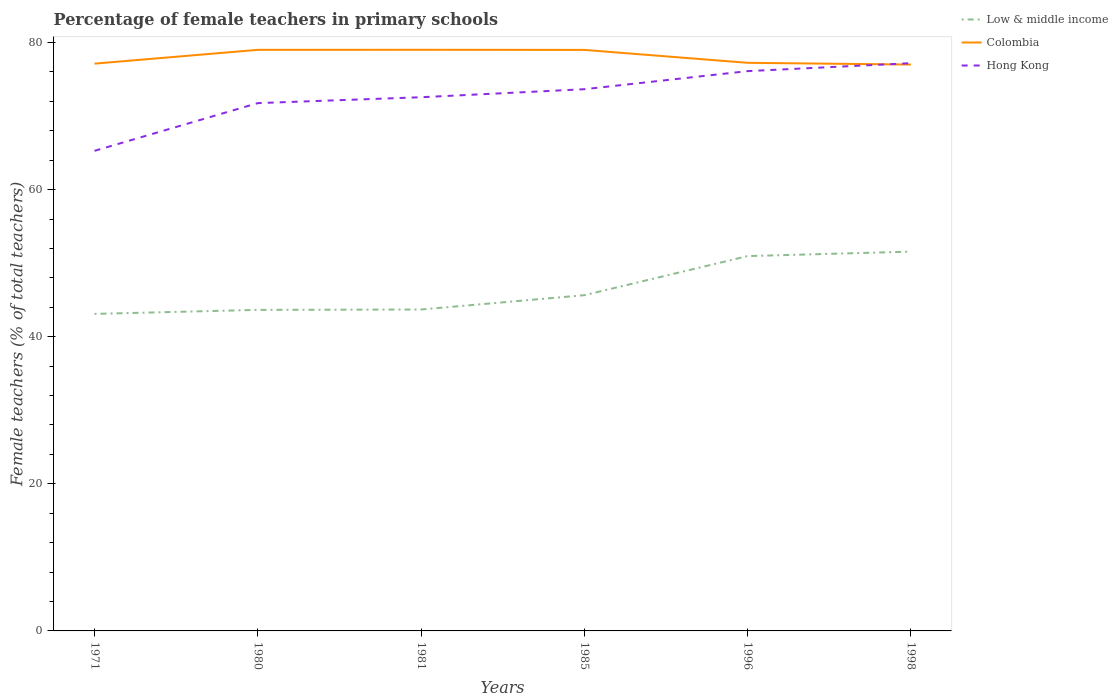Across all years, what is the maximum percentage of female teachers in Hong Kong?
Provide a succinct answer. 65.27. In which year was the percentage of female teachers in Colombia maximum?
Make the answer very short. 1998. What is the total percentage of female teachers in Hong Kong in the graph?
Your response must be concise. -0.8. What is the difference between the highest and the second highest percentage of female teachers in Hong Kong?
Your answer should be compact. 11.92. What is the difference between the highest and the lowest percentage of female teachers in Colombia?
Your response must be concise. 3. Is the percentage of female teachers in Hong Kong strictly greater than the percentage of female teachers in Low & middle income over the years?
Your answer should be very brief. No. Does the graph contain any zero values?
Keep it short and to the point. No. Where does the legend appear in the graph?
Provide a succinct answer. Top right. How are the legend labels stacked?
Offer a terse response. Vertical. What is the title of the graph?
Ensure brevity in your answer.  Percentage of female teachers in primary schools. What is the label or title of the Y-axis?
Your response must be concise. Female teachers (% of total teachers). What is the Female teachers (% of total teachers) of Low & middle income in 1971?
Your answer should be very brief. 43.1. What is the Female teachers (% of total teachers) in Colombia in 1971?
Your answer should be compact. 77.13. What is the Female teachers (% of total teachers) in Hong Kong in 1971?
Give a very brief answer. 65.27. What is the Female teachers (% of total teachers) of Low & middle income in 1980?
Offer a very short reply. 43.65. What is the Female teachers (% of total teachers) in Colombia in 1980?
Give a very brief answer. 79. What is the Female teachers (% of total teachers) in Hong Kong in 1980?
Your answer should be very brief. 71.76. What is the Female teachers (% of total teachers) in Low & middle income in 1981?
Your answer should be very brief. 43.7. What is the Female teachers (% of total teachers) in Colombia in 1981?
Make the answer very short. 79.01. What is the Female teachers (% of total teachers) of Hong Kong in 1981?
Make the answer very short. 72.56. What is the Female teachers (% of total teachers) of Low & middle income in 1985?
Your answer should be compact. 45.65. What is the Female teachers (% of total teachers) in Colombia in 1985?
Your response must be concise. 78.99. What is the Female teachers (% of total teachers) of Hong Kong in 1985?
Offer a very short reply. 73.65. What is the Female teachers (% of total teachers) in Low & middle income in 1996?
Make the answer very short. 50.96. What is the Female teachers (% of total teachers) of Colombia in 1996?
Your answer should be very brief. 77.24. What is the Female teachers (% of total teachers) in Hong Kong in 1996?
Offer a terse response. 76.11. What is the Female teachers (% of total teachers) in Low & middle income in 1998?
Ensure brevity in your answer.  51.57. What is the Female teachers (% of total teachers) of Colombia in 1998?
Your answer should be very brief. 77. What is the Female teachers (% of total teachers) in Hong Kong in 1998?
Ensure brevity in your answer.  77.19. Across all years, what is the maximum Female teachers (% of total teachers) of Low & middle income?
Offer a very short reply. 51.57. Across all years, what is the maximum Female teachers (% of total teachers) of Colombia?
Offer a very short reply. 79.01. Across all years, what is the maximum Female teachers (% of total teachers) in Hong Kong?
Provide a succinct answer. 77.19. Across all years, what is the minimum Female teachers (% of total teachers) of Low & middle income?
Ensure brevity in your answer.  43.1. Across all years, what is the minimum Female teachers (% of total teachers) of Colombia?
Your answer should be compact. 77. Across all years, what is the minimum Female teachers (% of total teachers) of Hong Kong?
Offer a terse response. 65.27. What is the total Female teachers (% of total teachers) in Low & middle income in the graph?
Ensure brevity in your answer.  278.63. What is the total Female teachers (% of total teachers) of Colombia in the graph?
Your answer should be compact. 468.38. What is the total Female teachers (% of total teachers) of Hong Kong in the graph?
Keep it short and to the point. 436.54. What is the difference between the Female teachers (% of total teachers) of Low & middle income in 1971 and that in 1980?
Your answer should be compact. -0.55. What is the difference between the Female teachers (% of total teachers) in Colombia in 1971 and that in 1980?
Your answer should be very brief. -1.88. What is the difference between the Female teachers (% of total teachers) of Hong Kong in 1971 and that in 1980?
Ensure brevity in your answer.  -6.49. What is the difference between the Female teachers (% of total teachers) in Low & middle income in 1971 and that in 1981?
Your answer should be compact. -0.6. What is the difference between the Female teachers (% of total teachers) of Colombia in 1971 and that in 1981?
Offer a terse response. -1.89. What is the difference between the Female teachers (% of total teachers) in Hong Kong in 1971 and that in 1981?
Provide a succinct answer. -7.29. What is the difference between the Female teachers (% of total teachers) of Low & middle income in 1971 and that in 1985?
Keep it short and to the point. -2.54. What is the difference between the Female teachers (% of total teachers) in Colombia in 1971 and that in 1985?
Offer a very short reply. -1.87. What is the difference between the Female teachers (% of total teachers) in Hong Kong in 1971 and that in 1985?
Keep it short and to the point. -8.38. What is the difference between the Female teachers (% of total teachers) in Low & middle income in 1971 and that in 1996?
Your answer should be compact. -7.86. What is the difference between the Female teachers (% of total teachers) of Colombia in 1971 and that in 1996?
Provide a short and direct response. -0.11. What is the difference between the Female teachers (% of total teachers) of Hong Kong in 1971 and that in 1996?
Offer a very short reply. -10.84. What is the difference between the Female teachers (% of total teachers) of Low & middle income in 1971 and that in 1998?
Your answer should be compact. -8.47. What is the difference between the Female teachers (% of total teachers) of Colombia in 1971 and that in 1998?
Make the answer very short. 0.12. What is the difference between the Female teachers (% of total teachers) of Hong Kong in 1971 and that in 1998?
Ensure brevity in your answer.  -11.92. What is the difference between the Female teachers (% of total teachers) of Low & middle income in 1980 and that in 1981?
Offer a very short reply. -0.05. What is the difference between the Female teachers (% of total teachers) of Colombia in 1980 and that in 1981?
Make the answer very short. -0.01. What is the difference between the Female teachers (% of total teachers) of Low & middle income in 1980 and that in 1985?
Ensure brevity in your answer.  -2. What is the difference between the Female teachers (% of total teachers) in Colombia in 1980 and that in 1985?
Your answer should be very brief. 0.01. What is the difference between the Female teachers (% of total teachers) in Hong Kong in 1980 and that in 1985?
Make the answer very short. -1.89. What is the difference between the Female teachers (% of total teachers) of Low & middle income in 1980 and that in 1996?
Ensure brevity in your answer.  -7.31. What is the difference between the Female teachers (% of total teachers) of Colombia in 1980 and that in 1996?
Your response must be concise. 1.76. What is the difference between the Female teachers (% of total teachers) of Hong Kong in 1980 and that in 1996?
Your response must be concise. -4.35. What is the difference between the Female teachers (% of total teachers) in Low & middle income in 1980 and that in 1998?
Offer a terse response. -7.92. What is the difference between the Female teachers (% of total teachers) of Colombia in 1980 and that in 1998?
Provide a succinct answer. 2. What is the difference between the Female teachers (% of total teachers) of Hong Kong in 1980 and that in 1998?
Your answer should be very brief. -5.43. What is the difference between the Female teachers (% of total teachers) of Low & middle income in 1981 and that in 1985?
Your answer should be very brief. -1.95. What is the difference between the Female teachers (% of total teachers) in Colombia in 1981 and that in 1985?
Your answer should be compact. 0.02. What is the difference between the Female teachers (% of total teachers) in Hong Kong in 1981 and that in 1985?
Offer a terse response. -1.09. What is the difference between the Female teachers (% of total teachers) in Low & middle income in 1981 and that in 1996?
Your answer should be compact. -7.26. What is the difference between the Female teachers (% of total teachers) in Colombia in 1981 and that in 1996?
Give a very brief answer. 1.77. What is the difference between the Female teachers (% of total teachers) of Hong Kong in 1981 and that in 1996?
Offer a very short reply. -3.55. What is the difference between the Female teachers (% of total teachers) in Low & middle income in 1981 and that in 1998?
Provide a short and direct response. -7.87. What is the difference between the Female teachers (% of total teachers) in Colombia in 1981 and that in 1998?
Offer a terse response. 2.01. What is the difference between the Female teachers (% of total teachers) in Hong Kong in 1981 and that in 1998?
Give a very brief answer. -4.63. What is the difference between the Female teachers (% of total teachers) of Low & middle income in 1985 and that in 1996?
Give a very brief answer. -5.31. What is the difference between the Female teachers (% of total teachers) of Colombia in 1985 and that in 1996?
Offer a terse response. 1.75. What is the difference between the Female teachers (% of total teachers) in Hong Kong in 1985 and that in 1996?
Your response must be concise. -2.46. What is the difference between the Female teachers (% of total teachers) of Low & middle income in 1985 and that in 1998?
Provide a succinct answer. -5.92. What is the difference between the Female teachers (% of total teachers) of Colombia in 1985 and that in 1998?
Ensure brevity in your answer.  1.99. What is the difference between the Female teachers (% of total teachers) of Hong Kong in 1985 and that in 1998?
Offer a very short reply. -3.54. What is the difference between the Female teachers (% of total teachers) in Low & middle income in 1996 and that in 1998?
Your answer should be very brief. -0.61. What is the difference between the Female teachers (% of total teachers) of Colombia in 1996 and that in 1998?
Your answer should be very brief. 0.24. What is the difference between the Female teachers (% of total teachers) of Hong Kong in 1996 and that in 1998?
Provide a succinct answer. -1.08. What is the difference between the Female teachers (% of total teachers) of Low & middle income in 1971 and the Female teachers (% of total teachers) of Colombia in 1980?
Give a very brief answer. -35.9. What is the difference between the Female teachers (% of total teachers) of Low & middle income in 1971 and the Female teachers (% of total teachers) of Hong Kong in 1980?
Keep it short and to the point. -28.66. What is the difference between the Female teachers (% of total teachers) of Colombia in 1971 and the Female teachers (% of total teachers) of Hong Kong in 1980?
Provide a succinct answer. 5.37. What is the difference between the Female teachers (% of total teachers) of Low & middle income in 1971 and the Female teachers (% of total teachers) of Colombia in 1981?
Make the answer very short. -35.91. What is the difference between the Female teachers (% of total teachers) in Low & middle income in 1971 and the Female teachers (% of total teachers) in Hong Kong in 1981?
Keep it short and to the point. -29.46. What is the difference between the Female teachers (% of total teachers) in Colombia in 1971 and the Female teachers (% of total teachers) in Hong Kong in 1981?
Offer a very short reply. 4.57. What is the difference between the Female teachers (% of total teachers) of Low & middle income in 1971 and the Female teachers (% of total teachers) of Colombia in 1985?
Your response must be concise. -35.89. What is the difference between the Female teachers (% of total teachers) of Low & middle income in 1971 and the Female teachers (% of total teachers) of Hong Kong in 1985?
Ensure brevity in your answer.  -30.55. What is the difference between the Female teachers (% of total teachers) in Colombia in 1971 and the Female teachers (% of total teachers) in Hong Kong in 1985?
Offer a terse response. 3.47. What is the difference between the Female teachers (% of total teachers) of Low & middle income in 1971 and the Female teachers (% of total teachers) of Colombia in 1996?
Provide a succinct answer. -34.14. What is the difference between the Female teachers (% of total teachers) in Low & middle income in 1971 and the Female teachers (% of total teachers) in Hong Kong in 1996?
Keep it short and to the point. -33.01. What is the difference between the Female teachers (% of total teachers) of Low & middle income in 1971 and the Female teachers (% of total teachers) of Colombia in 1998?
Ensure brevity in your answer.  -33.9. What is the difference between the Female teachers (% of total teachers) of Low & middle income in 1971 and the Female teachers (% of total teachers) of Hong Kong in 1998?
Your response must be concise. -34.09. What is the difference between the Female teachers (% of total teachers) in Colombia in 1971 and the Female teachers (% of total teachers) in Hong Kong in 1998?
Your response must be concise. -0.07. What is the difference between the Female teachers (% of total teachers) of Low & middle income in 1980 and the Female teachers (% of total teachers) of Colombia in 1981?
Your answer should be very brief. -35.36. What is the difference between the Female teachers (% of total teachers) in Low & middle income in 1980 and the Female teachers (% of total teachers) in Hong Kong in 1981?
Keep it short and to the point. -28.91. What is the difference between the Female teachers (% of total teachers) in Colombia in 1980 and the Female teachers (% of total teachers) in Hong Kong in 1981?
Your answer should be very brief. 6.44. What is the difference between the Female teachers (% of total teachers) in Low & middle income in 1980 and the Female teachers (% of total teachers) in Colombia in 1985?
Offer a very short reply. -35.34. What is the difference between the Female teachers (% of total teachers) of Low & middle income in 1980 and the Female teachers (% of total teachers) of Hong Kong in 1985?
Offer a very short reply. -30. What is the difference between the Female teachers (% of total teachers) of Colombia in 1980 and the Female teachers (% of total teachers) of Hong Kong in 1985?
Keep it short and to the point. 5.35. What is the difference between the Female teachers (% of total teachers) of Low & middle income in 1980 and the Female teachers (% of total teachers) of Colombia in 1996?
Your answer should be compact. -33.59. What is the difference between the Female teachers (% of total teachers) of Low & middle income in 1980 and the Female teachers (% of total teachers) of Hong Kong in 1996?
Your answer should be compact. -32.46. What is the difference between the Female teachers (% of total teachers) of Colombia in 1980 and the Female teachers (% of total teachers) of Hong Kong in 1996?
Your answer should be very brief. 2.89. What is the difference between the Female teachers (% of total teachers) in Low & middle income in 1980 and the Female teachers (% of total teachers) in Colombia in 1998?
Your answer should be very brief. -33.36. What is the difference between the Female teachers (% of total teachers) of Low & middle income in 1980 and the Female teachers (% of total teachers) of Hong Kong in 1998?
Provide a short and direct response. -33.54. What is the difference between the Female teachers (% of total teachers) of Colombia in 1980 and the Female teachers (% of total teachers) of Hong Kong in 1998?
Offer a terse response. 1.81. What is the difference between the Female teachers (% of total teachers) of Low & middle income in 1981 and the Female teachers (% of total teachers) of Colombia in 1985?
Make the answer very short. -35.29. What is the difference between the Female teachers (% of total teachers) of Low & middle income in 1981 and the Female teachers (% of total teachers) of Hong Kong in 1985?
Provide a succinct answer. -29.95. What is the difference between the Female teachers (% of total teachers) of Colombia in 1981 and the Female teachers (% of total teachers) of Hong Kong in 1985?
Your response must be concise. 5.36. What is the difference between the Female teachers (% of total teachers) in Low & middle income in 1981 and the Female teachers (% of total teachers) in Colombia in 1996?
Provide a short and direct response. -33.54. What is the difference between the Female teachers (% of total teachers) in Low & middle income in 1981 and the Female teachers (% of total teachers) in Hong Kong in 1996?
Your answer should be very brief. -32.41. What is the difference between the Female teachers (% of total teachers) in Colombia in 1981 and the Female teachers (% of total teachers) in Hong Kong in 1996?
Provide a succinct answer. 2.9. What is the difference between the Female teachers (% of total teachers) in Low & middle income in 1981 and the Female teachers (% of total teachers) in Colombia in 1998?
Offer a very short reply. -33.3. What is the difference between the Female teachers (% of total teachers) in Low & middle income in 1981 and the Female teachers (% of total teachers) in Hong Kong in 1998?
Give a very brief answer. -33.49. What is the difference between the Female teachers (% of total teachers) of Colombia in 1981 and the Female teachers (% of total teachers) of Hong Kong in 1998?
Your response must be concise. 1.82. What is the difference between the Female teachers (% of total teachers) of Low & middle income in 1985 and the Female teachers (% of total teachers) of Colombia in 1996?
Make the answer very short. -31.59. What is the difference between the Female teachers (% of total teachers) in Low & middle income in 1985 and the Female teachers (% of total teachers) in Hong Kong in 1996?
Offer a terse response. -30.46. What is the difference between the Female teachers (% of total teachers) in Colombia in 1985 and the Female teachers (% of total teachers) in Hong Kong in 1996?
Your answer should be compact. 2.88. What is the difference between the Female teachers (% of total teachers) in Low & middle income in 1985 and the Female teachers (% of total teachers) in Colombia in 1998?
Your response must be concise. -31.36. What is the difference between the Female teachers (% of total teachers) in Low & middle income in 1985 and the Female teachers (% of total teachers) in Hong Kong in 1998?
Ensure brevity in your answer.  -31.55. What is the difference between the Female teachers (% of total teachers) of Colombia in 1985 and the Female teachers (% of total teachers) of Hong Kong in 1998?
Keep it short and to the point. 1.8. What is the difference between the Female teachers (% of total teachers) in Low & middle income in 1996 and the Female teachers (% of total teachers) in Colombia in 1998?
Make the answer very short. -26.04. What is the difference between the Female teachers (% of total teachers) in Low & middle income in 1996 and the Female teachers (% of total teachers) in Hong Kong in 1998?
Keep it short and to the point. -26.23. What is the difference between the Female teachers (% of total teachers) in Colombia in 1996 and the Female teachers (% of total teachers) in Hong Kong in 1998?
Provide a short and direct response. 0.05. What is the average Female teachers (% of total teachers) of Low & middle income per year?
Keep it short and to the point. 46.44. What is the average Female teachers (% of total teachers) of Colombia per year?
Ensure brevity in your answer.  78.06. What is the average Female teachers (% of total teachers) in Hong Kong per year?
Offer a very short reply. 72.76. In the year 1971, what is the difference between the Female teachers (% of total teachers) of Low & middle income and Female teachers (% of total teachers) of Colombia?
Your answer should be compact. -34.02. In the year 1971, what is the difference between the Female teachers (% of total teachers) in Low & middle income and Female teachers (% of total teachers) in Hong Kong?
Ensure brevity in your answer.  -22.17. In the year 1971, what is the difference between the Female teachers (% of total teachers) of Colombia and Female teachers (% of total teachers) of Hong Kong?
Make the answer very short. 11.85. In the year 1980, what is the difference between the Female teachers (% of total teachers) in Low & middle income and Female teachers (% of total teachers) in Colombia?
Your response must be concise. -35.35. In the year 1980, what is the difference between the Female teachers (% of total teachers) in Low & middle income and Female teachers (% of total teachers) in Hong Kong?
Give a very brief answer. -28.11. In the year 1980, what is the difference between the Female teachers (% of total teachers) in Colombia and Female teachers (% of total teachers) in Hong Kong?
Offer a terse response. 7.24. In the year 1981, what is the difference between the Female teachers (% of total teachers) of Low & middle income and Female teachers (% of total teachers) of Colombia?
Ensure brevity in your answer.  -35.31. In the year 1981, what is the difference between the Female teachers (% of total teachers) of Low & middle income and Female teachers (% of total teachers) of Hong Kong?
Make the answer very short. -28.86. In the year 1981, what is the difference between the Female teachers (% of total teachers) in Colombia and Female teachers (% of total teachers) in Hong Kong?
Provide a succinct answer. 6.45. In the year 1985, what is the difference between the Female teachers (% of total teachers) in Low & middle income and Female teachers (% of total teachers) in Colombia?
Your answer should be compact. -33.35. In the year 1985, what is the difference between the Female teachers (% of total teachers) of Low & middle income and Female teachers (% of total teachers) of Hong Kong?
Your answer should be compact. -28. In the year 1985, what is the difference between the Female teachers (% of total teachers) in Colombia and Female teachers (% of total teachers) in Hong Kong?
Offer a very short reply. 5.34. In the year 1996, what is the difference between the Female teachers (% of total teachers) of Low & middle income and Female teachers (% of total teachers) of Colombia?
Provide a succinct answer. -26.28. In the year 1996, what is the difference between the Female teachers (% of total teachers) in Low & middle income and Female teachers (% of total teachers) in Hong Kong?
Give a very brief answer. -25.15. In the year 1996, what is the difference between the Female teachers (% of total teachers) in Colombia and Female teachers (% of total teachers) in Hong Kong?
Keep it short and to the point. 1.13. In the year 1998, what is the difference between the Female teachers (% of total teachers) in Low & middle income and Female teachers (% of total teachers) in Colombia?
Offer a terse response. -25.44. In the year 1998, what is the difference between the Female teachers (% of total teachers) of Low & middle income and Female teachers (% of total teachers) of Hong Kong?
Your answer should be very brief. -25.62. In the year 1998, what is the difference between the Female teachers (% of total teachers) of Colombia and Female teachers (% of total teachers) of Hong Kong?
Make the answer very short. -0.19. What is the ratio of the Female teachers (% of total teachers) of Low & middle income in 1971 to that in 1980?
Ensure brevity in your answer.  0.99. What is the ratio of the Female teachers (% of total teachers) of Colombia in 1971 to that in 1980?
Make the answer very short. 0.98. What is the ratio of the Female teachers (% of total teachers) in Hong Kong in 1971 to that in 1980?
Your response must be concise. 0.91. What is the ratio of the Female teachers (% of total teachers) in Low & middle income in 1971 to that in 1981?
Offer a terse response. 0.99. What is the ratio of the Female teachers (% of total teachers) of Colombia in 1971 to that in 1981?
Give a very brief answer. 0.98. What is the ratio of the Female teachers (% of total teachers) in Hong Kong in 1971 to that in 1981?
Ensure brevity in your answer.  0.9. What is the ratio of the Female teachers (% of total teachers) of Low & middle income in 1971 to that in 1985?
Keep it short and to the point. 0.94. What is the ratio of the Female teachers (% of total teachers) of Colombia in 1971 to that in 1985?
Your response must be concise. 0.98. What is the ratio of the Female teachers (% of total teachers) of Hong Kong in 1971 to that in 1985?
Your response must be concise. 0.89. What is the ratio of the Female teachers (% of total teachers) of Low & middle income in 1971 to that in 1996?
Make the answer very short. 0.85. What is the ratio of the Female teachers (% of total teachers) in Colombia in 1971 to that in 1996?
Offer a terse response. 1. What is the ratio of the Female teachers (% of total teachers) in Hong Kong in 1971 to that in 1996?
Offer a terse response. 0.86. What is the ratio of the Female teachers (% of total teachers) in Low & middle income in 1971 to that in 1998?
Ensure brevity in your answer.  0.84. What is the ratio of the Female teachers (% of total teachers) of Hong Kong in 1971 to that in 1998?
Keep it short and to the point. 0.85. What is the ratio of the Female teachers (% of total teachers) of Hong Kong in 1980 to that in 1981?
Provide a short and direct response. 0.99. What is the ratio of the Female teachers (% of total teachers) of Low & middle income in 1980 to that in 1985?
Your answer should be very brief. 0.96. What is the ratio of the Female teachers (% of total teachers) in Colombia in 1980 to that in 1985?
Offer a terse response. 1. What is the ratio of the Female teachers (% of total teachers) in Hong Kong in 1980 to that in 1985?
Provide a short and direct response. 0.97. What is the ratio of the Female teachers (% of total teachers) in Low & middle income in 1980 to that in 1996?
Offer a very short reply. 0.86. What is the ratio of the Female teachers (% of total teachers) of Colombia in 1980 to that in 1996?
Provide a short and direct response. 1.02. What is the ratio of the Female teachers (% of total teachers) in Hong Kong in 1980 to that in 1996?
Provide a short and direct response. 0.94. What is the ratio of the Female teachers (% of total teachers) of Low & middle income in 1980 to that in 1998?
Ensure brevity in your answer.  0.85. What is the ratio of the Female teachers (% of total teachers) of Colombia in 1980 to that in 1998?
Your response must be concise. 1.03. What is the ratio of the Female teachers (% of total teachers) in Hong Kong in 1980 to that in 1998?
Make the answer very short. 0.93. What is the ratio of the Female teachers (% of total teachers) in Low & middle income in 1981 to that in 1985?
Your answer should be very brief. 0.96. What is the ratio of the Female teachers (% of total teachers) of Hong Kong in 1981 to that in 1985?
Your response must be concise. 0.99. What is the ratio of the Female teachers (% of total teachers) in Low & middle income in 1981 to that in 1996?
Give a very brief answer. 0.86. What is the ratio of the Female teachers (% of total teachers) in Colombia in 1981 to that in 1996?
Provide a succinct answer. 1.02. What is the ratio of the Female teachers (% of total teachers) in Hong Kong in 1981 to that in 1996?
Your answer should be compact. 0.95. What is the ratio of the Female teachers (% of total teachers) of Low & middle income in 1981 to that in 1998?
Ensure brevity in your answer.  0.85. What is the ratio of the Female teachers (% of total teachers) of Colombia in 1981 to that in 1998?
Your response must be concise. 1.03. What is the ratio of the Female teachers (% of total teachers) in Low & middle income in 1985 to that in 1996?
Ensure brevity in your answer.  0.9. What is the ratio of the Female teachers (% of total teachers) of Colombia in 1985 to that in 1996?
Provide a succinct answer. 1.02. What is the ratio of the Female teachers (% of total teachers) of Low & middle income in 1985 to that in 1998?
Offer a very short reply. 0.89. What is the ratio of the Female teachers (% of total teachers) in Colombia in 1985 to that in 1998?
Offer a very short reply. 1.03. What is the ratio of the Female teachers (% of total teachers) of Hong Kong in 1985 to that in 1998?
Give a very brief answer. 0.95. What is the ratio of the Female teachers (% of total teachers) of Hong Kong in 1996 to that in 1998?
Offer a very short reply. 0.99. What is the difference between the highest and the second highest Female teachers (% of total teachers) of Low & middle income?
Your answer should be compact. 0.61. What is the difference between the highest and the second highest Female teachers (% of total teachers) of Colombia?
Provide a succinct answer. 0.01. What is the difference between the highest and the second highest Female teachers (% of total teachers) of Hong Kong?
Provide a succinct answer. 1.08. What is the difference between the highest and the lowest Female teachers (% of total teachers) in Low & middle income?
Your answer should be very brief. 8.47. What is the difference between the highest and the lowest Female teachers (% of total teachers) in Colombia?
Give a very brief answer. 2.01. What is the difference between the highest and the lowest Female teachers (% of total teachers) of Hong Kong?
Offer a very short reply. 11.92. 